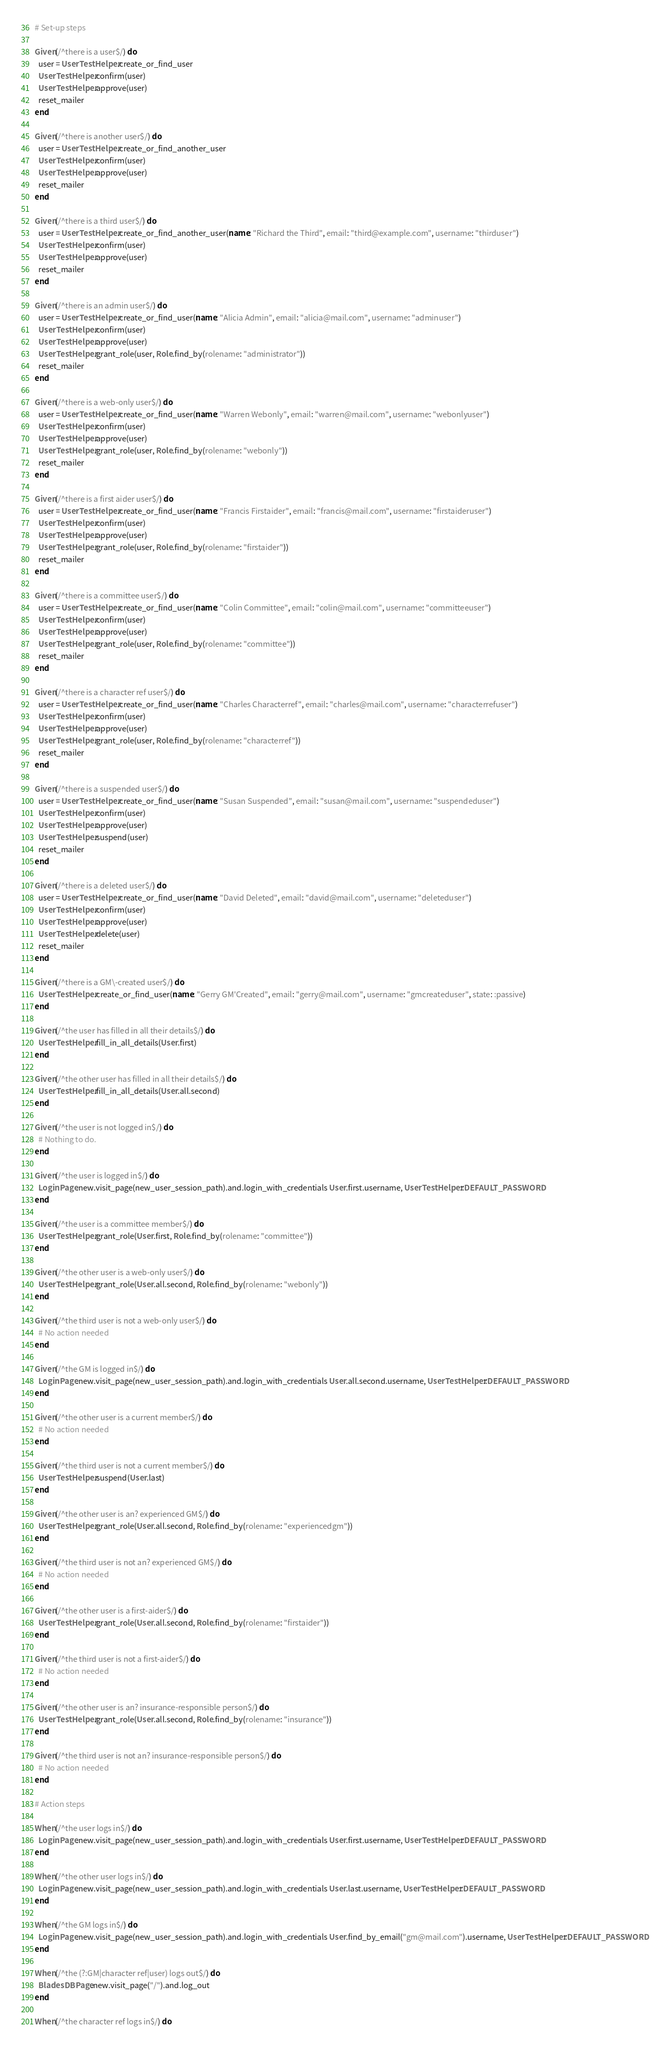<code> <loc_0><loc_0><loc_500><loc_500><_Ruby_># Set-up steps

Given(/^there is a user$/) do
  user = UserTestHelper.create_or_find_user
  UserTestHelper.confirm(user)
  UserTestHelper.approve(user)
  reset_mailer
end

Given(/^there is another user$/) do
  user = UserTestHelper.create_or_find_another_user
  UserTestHelper.confirm(user)
  UserTestHelper.approve(user)
  reset_mailer
end

Given(/^there is a third user$/) do
  user = UserTestHelper.create_or_find_another_user(name: "Richard the Third", email: "third@example.com", username: "thirduser")
  UserTestHelper.confirm(user)
  UserTestHelper.approve(user)
  reset_mailer
end

Given(/^there is an admin user$/) do
  user = UserTestHelper.create_or_find_user(name: "Alicia Admin", email: "alicia@mail.com", username: "adminuser")
  UserTestHelper.confirm(user)
  UserTestHelper.approve(user)
  UserTestHelper.grant_role(user, Role.find_by(rolename: "administrator"))
  reset_mailer
end

Given(/^there is a web-only user$/) do
  user = UserTestHelper.create_or_find_user(name: "Warren Webonly", email: "warren@mail.com", username: "webonlyuser")
  UserTestHelper.confirm(user)
  UserTestHelper.approve(user)
  UserTestHelper.grant_role(user, Role.find_by(rolename: "webonly"))
  reset_mailer
end

Given(/^there is a first aider user$/) do
  user = UserTestHelper.create_or_find_user(name: "Francis Firstaider", email: "francis@mail.com", username: "firstaideruser")
  UserTestHelper.confirm(user)
  UserTestHelper.approve(user)
  UserTestHelper.grant_role(user, Role.find_by(rolename: "firstaider"))
  reset_mailer
end

Given(/^there is a committee user$/) do
  user = UserTestHelper.create_or_find_user(name: "Colin Committee", email: "colin@mail.com", username: "committeeuser")
  UserTestHelper.confirm(user)
  UserTestHelper.approve(user)
  UserTestHelper.grant_role(user, Role.find_by(rolename: "committee"))
  reset_mailer
end

Given(/^there is a character ref user$/) do
  user = UserTestHelper.create_or_find_user(name: "Charles Characterref", email: "charles@mail.com", username: "characterrefuser")
  UserTestHelper.confirm(user)
  UserTestHelper.approve(user)
  UserTestHelper.grant_role(user, Role.find_by(rolename: "characterref"))
  reset_mailer
end

Given(/^there is a suspended user$/) do
  user = UserTestHelper.create_or_find_user(name: "Susan Suspended", email: "susan@mail.com", username: "suspendeduser")
  UserTestHelper.confirm(user)
  UserTestHelper.approve(user)
  UserTestHelper.suspend(user)
  reset_mailer
end

Given(/^there is a deleted user$/) do
  user = UserTestHelper.create_or_find_user(name: "David Deleted", email: "david@mail.com", username: "deleteduser")
  UserTestHelper.confirm(user)
  UserTestHelper.approve(user)
  UserTestHelper.delete(user)
  reset_mailer
end

Given(/^there is a GM\-created user$/) do
  UserTestHelper.create_or_find_user(name: "Gerry GM'Created", email: "gerry@mail.com", username: "gmcreateduser", state: :passive)
end

Given(/^the user has filled in all their details$/) do
  UserTestHelper.fill_in_all_details(User.first)
end

Given(/^the other user has filled in all their details$/) do
  UserTestHelper.fill_in_all_details(User.all.second)
end

Given(/^the user is not logged in$/) do
  # Nothing to do.
end

Given(/^the user is logged in$/) do
  LoginPage.new.visit_page(new_user_session_path).and.login_with_credentials User.first.username, UserTestHelper::DEFAULT_PASSWORD
end

Given(/^the user is a committee member$/) do
  UserTestHelper.grant_role(User.first, Role.find_by(rolename: "committee"))
end

Given(/^the other user is a web-only user$/) do
  UserTestHelper.grant_role(User.all.second, Role.find_by(rolename: "webonly"))
end

Given(/^the third user is not a web-only user$/) do
  # No action needed
end

Given(/^the GM is logged in$/) do
  LoginPage.new.visit_page(new_user_session_path).and.login_with_credentials User.all.second.username, UserTestHelper::DEFAULT_PASSWORD
end

Given(/^the other user is a current member$/) do
  # No action needed
end

Given(/^the third user is not a current member$/) do
  UserTestHelper.suspend(User.last)
end

Given(/^the other user is an? experienced GM$/) do
  UserTestHelper.grant_role(User.all.second, Role.find_by(rolename: "experiencedgm"))
end

Given(/^the third user is not an? experienced GM$/) do
  # No action needed
end

Given(/^the other user is a first-aider$/) do
  UserTestHelper.grant_role(User.all.second, Role.find_by(rolename: "firstaider"))
end

Given(/^the third user is not a first-aider$/) do
  # No action needed
end

Given(/^the other user is an? insurance-responsible person$/) do
  UserTestHelper.grant_role(User.all.second, Role.find_by(rolename: "insurance"))
end

Given(/^the third user is not an? insurance-responsible person$/) do
  # No action needed
end

# Action steps

When(/^the user logs in$/) do
  LoginPage.new.visit_page(new_user_session_path).and.login_with_credentials User.first.username, UserTestHelper::DEFAULT_PASSWORD
end

When(/^the other user logs in$/) do
  LoginPage.new.visit_page(new_user_session_path).and.login_with_credentials User.last.username, UserTestHelper::DEFAULT_PASSWORD
end

When(/^the GM logs in$/) do
  LoginPage.new.visit_page(new_user_session_path).and.login_with_credentials User.find_by_email("gm@mail.com").username, UserTestHelper::DEFAULT_PASSWORD
end

When(/^the (?:GM|character ref|user) logs out$/) do
  BladesDBPage.new.visit_page("/").and.log_out
end

When(/^the character ref logs in$/) do</code> 